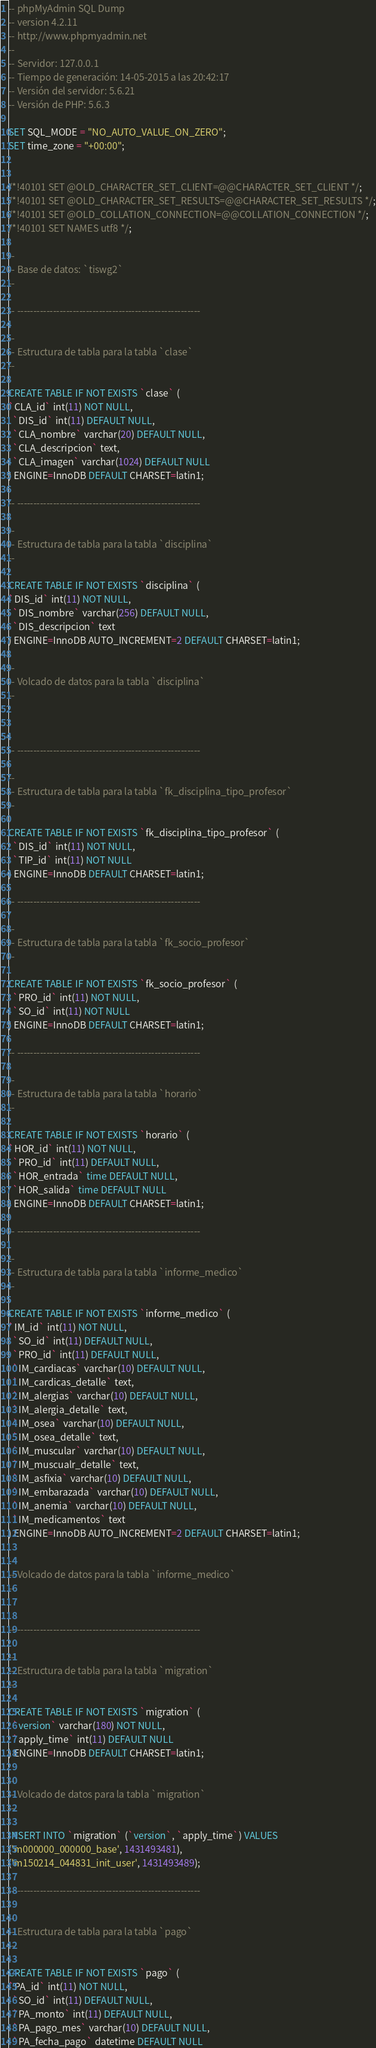<code> <loc_0><loc_0><loc_500><loc_500><_SQL_>-- phpMyAdmin SQL Dump
-- version 4.2.11
-- http://www.phpmyadmin.net
--
-- Servidor: 127.0.0.1
-- Tiempo de generación: 14-05-2015 a las 20:42:17
-- Versión del servidor: 5.6.21
-- Versión de PHP: 5.6.3

SET SQL_MODE = "NO_AUTO_VALUE_ON_ZERO";
SET time_zone = "+00:00";


/*!40101 SET @OLD_CHARACTER_SET_CLIENT=@@CHARACTER_SET_CLIENT */;
/*!40101 SET @OLD_CHARACTER_SET_RESULTS=@@CHARACTER_SET_RESULTS */;
/*!40101 SET @OLD_COLLATION_CONNECTION=@@COLLATION_CONNECTION */;
/*!40101 SET NAMES utf8 */;

--
-- Base de datos: `tiswg2`
--

-- --------------------------------------------------------

--
-- Estructura de tabla para la tabla `clase`
--

CREATE TABLE IF NOT EXISTS `clase` (
`CLA_id` int(11) NOT NULL,
  `DIS_id` int(11) DEFAULT NULL,
  `CLA_nombre` varchar(20) DEFAULT NULL,
  `CLA_descripcion` text,
  `CLA_imagen` varchar(1024) DEFAULT NULL
) ENGINE=InnoDB DEFAULT CHARSET=latin1;

-- --------------------------------------------------------

--
-- Estructura de tabla para la tabla `disciplina`
--

CREATE TABLE IF NOT EXISTS `disciplina` (
`DIS_id` int(11) NOT NULL,
  `DIS_nombre` varchar(256) DEFAULT NULL,
  `DIS_descripcion` text
) ENGINE=InnoDB AUTO_INCREMENT=2 DEFAULT CHARSET=latin1;

--
-- Volcado de datos para la tabla `disciplina`
--



-- --------------------------------------------------------

--
-- Estructura de tabla para la tabla `fk_disciplina_tipo_profesor`
--

CREATE TABLE IF NOT EXISTS `fk_disciplina_tipo_profesor` (
  `DIS_id` int(11) NOT NULL,
  `TIP_id` int(11) NOT NULL
) ENGINE=InnoDB DEFAULT CHARSET=latin1;

-- --------------------------------------------------------

--
-- Estructura de tabla para la tabla `fk_socio_profesor`
--

CREATE TABLE IF NOT EXISTS `fk_socio_profesor` (
  `PRO_id` int(11) NOT NULL,
  `SO_id` int(11) NOT NULL
) ENGINE=InnoDB DEFAULT CHARSET=latin1;

-- --------------------------------------------------------

--
-- Estructura de tabla para la tabla `horario`
--

CREATE TABLE IF NOT EXISTS `horario` (
`HOR_id` int(11) NOT NULL,
  `PRO_id` int(11) DEFAULT NULL,
  `HOR_entrada` time DEFAULT NULL,
  `HOR_salida` time DEFAULT NULL
) ENGINE=InnoDB DEFAULT CHARSET=latin1;

-- --------------------------------------------------------

--
-- Estructura de tabla para la tabla `informe_medico`
--

CREATE TABLE IF NOT EXISTS `informe_medico` (
`IM_id` int(11) NOT NULL,
  `SO_id` int(11) DEFAULT NULL,
  `PRO_id` int(11) DEFAULT NULL,
  `IM_cardiacas` varchar(10) DEFAULT NULL,
  `IM_cardicas_detalle` text,
  `IM_alergias` varchar(10) DEFAULT NULL,
  `IM_alergia_detalle` text,
  `IM_osea` varchar(10) DEFAULT NULL,
  `IM_osea_detalle` text,
  `IM_muscular` varchar(10) DEFAULT NULL,
  `IM_muscualr_detalle` text,
  `IM_asfixia` varchar(10) DEFAULT NULL,
  `IM_embarazada` varchar(10) DEFAULT NULL,
  `IM_anemia` varchar(10) DEFAULT NULL,
  `IM_medicamentos` text
) ENGINE=InnoDB AUTO_INCREMENT=2 DEFAULT CHARSET=latin1;

--
-- Volcado de datos para la tabla `informe_medico`
--


-- --------------------------------------------------------

--
-- Estructura de tabla para la tabla `migration`
--

CREATE TABLE IF NOT EXISTS `migration` (
  `version` varchar(180) NOT NULL,
  `apply_time` int(11) DEFAULT NULL
) ENGINE=InnoDB DEFAULT CHARSET=latin1;

--
-- Volcado de datos para la tabla `migration`
--

INSERT INTO `migration` (`version`, `apply_time`) VALUES
('m000000_000000_base', 1431493481),
('m150214_044831_init_user', 1431493489);

-- --------------------------------------------------------

--
-- Estructura de tabla para la tabla `pago`
--

CREATE TABLE IF NOT EXISTS `pago` (
`PA_id` int(11) NOT NULL,
  `SO_id` int(11) DEFAULT NULL,
  `PA_monto` int(11) DEFAULT NULL,
  `PA_pago_mes` varchar(10) DEFAULT NULL,
  `PA_fecha_pago` datetime DEFAULT NULL</code> 